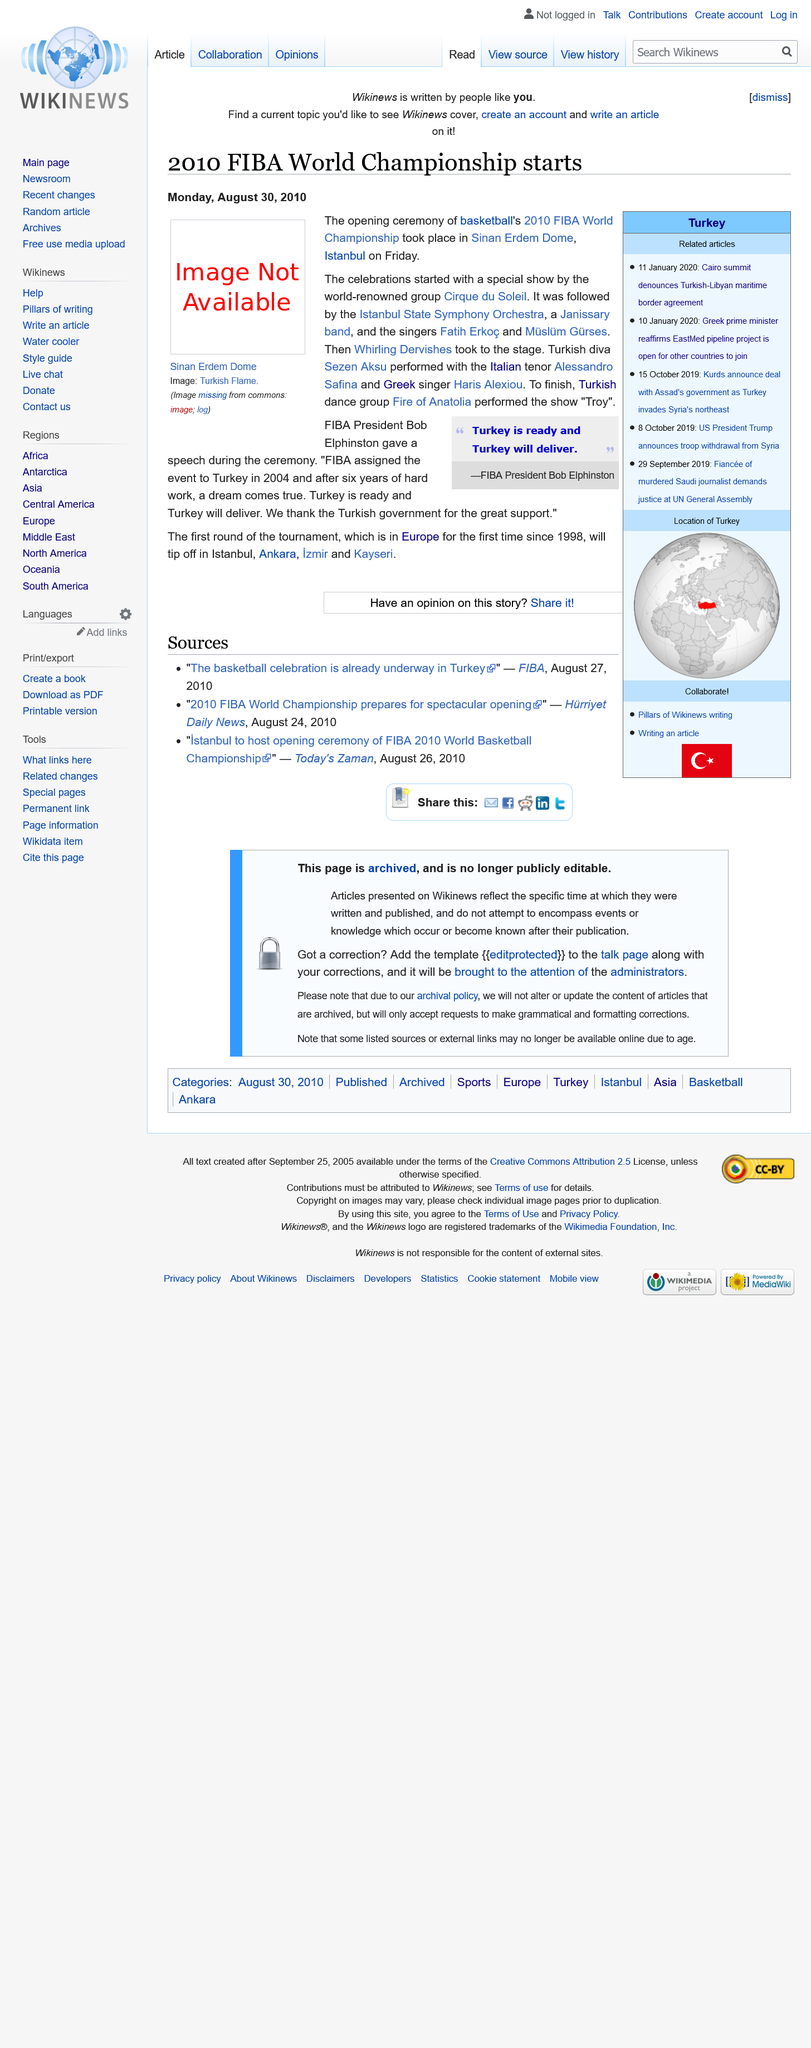List a handful of essential elements in this visual. The answer is yes, FIBA President Bob Elphinston gave a speech during the ceremony. The opening ceremony of the 2010 FIBA World Championship took place in the Sinan Erdem Dome in Istanbul, Turkey. The FIBA World Championship was last held in Europe in 1998. 